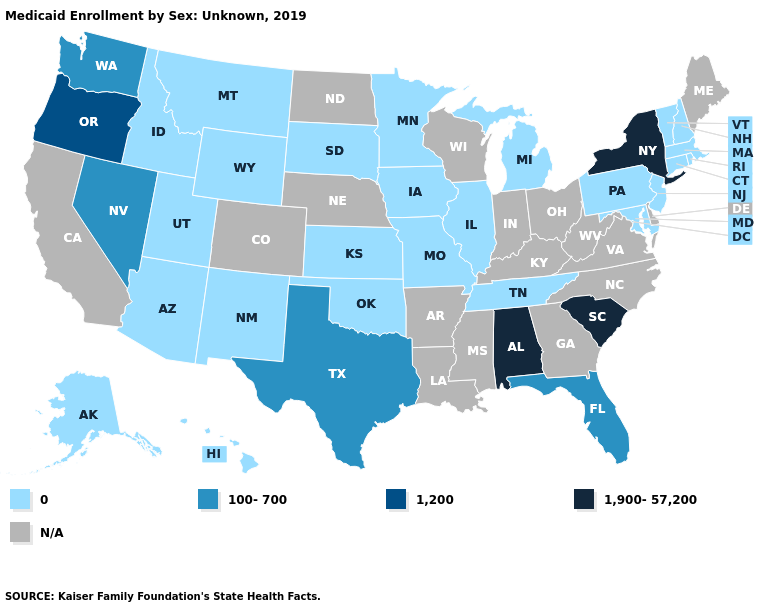Does Alabama have the lowest value in the USA?
Answer briefly. No. What is the value of Rhode Island?
Quick response, please. 0. Among the states that border New York , which have the lowest value?
Give a very brief answer. Connecticut, Massachusetts, New Jersey, Pennsylvania, Vermont. Name the states that have a value in the range 100-700?
Be succinct. Florida, Nevada, Texas, Washington. What is the lowest value in the USA?
Give a very brief answer. 0. Name the states that have a value in the range N/A?
Answer briefly. Arkansas, California, Colorado, Delaware, Georgia, Indiana, Kentucky, Louisiana, Maine, Mississippi, Nebraska, North Carolina, North Dakota, Ohio, Virginia, West Virginia, Wisconsin. What is the highest value in the USA?
Concise answer only. 1,900-57,200. Among the states that border Ohio , which have the highest value?
Quick response, please. Michigan, Pennsylvania. What is the value of Delaware?
Write a very short answer. N/A. Does the first symbol in the legend represent the smallest category?
Answer briefly. Yes. Which states hav the highest value in the South?
Quick response, please. Alabama, South Carolina. Does the first symbol in the legend represent the smallest category?
Quick response, please. Yes. What is the value of New York?
Answer briefly. 1,900-57,200. 